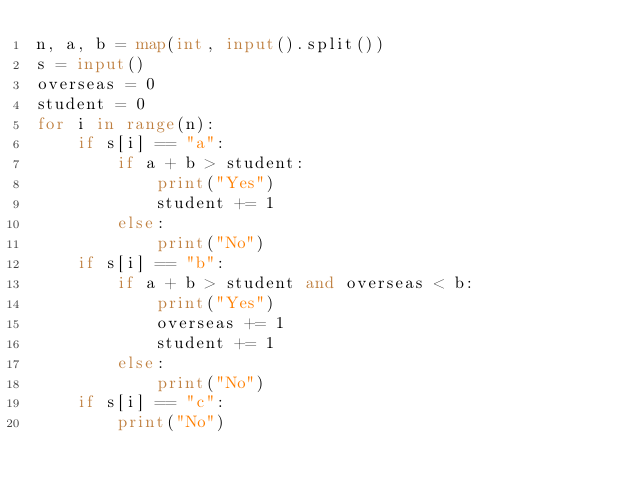<code> <loc_0><loc_0><loc_500><loc_500><_Python_>n, a, b = map(int, input().split())
s = input()
overseas = 0
student = 0
for i in range(n):
    if s[i] == "a":
        if a + b > student:
            print("Yes")
            student += 1
        else:
            print("No")
    if s[i] == "b":
        if a + b > student and overseas < b:
            print("Yes")
            overseas += 1
            student += 1
        else:
            print("No")
    if s[i] == "c":
        print("No")</code> 